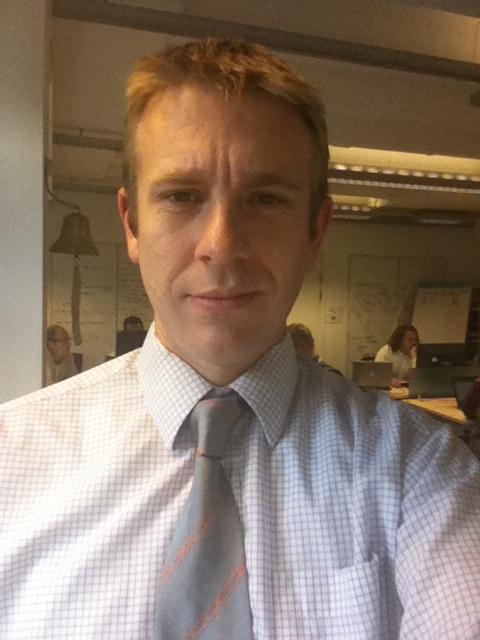Is this man taking a selfie?
Answer briefly. Yes. What color is the person's shirt?
Concise answer only. White. What color tie is he wearing?
Quick response, please. Gray. Is the man rich?
Write a very short answer. No. What is hanging on the wall?
Quick response, please. Bell. Is this man clean shaven?
Short answer required. Yes. Is he wearing glasses?
Write a very short answer. No. 